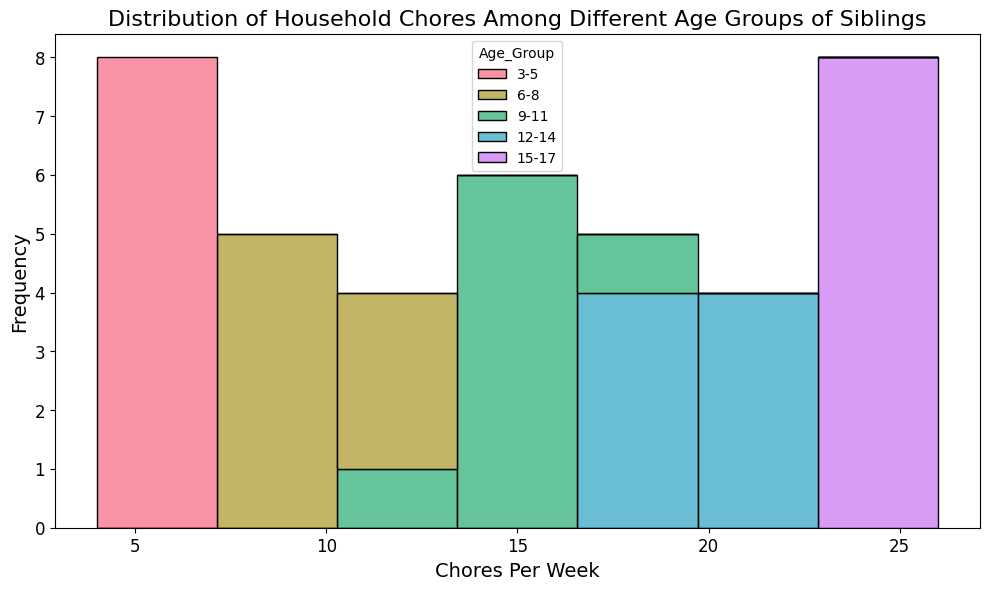How many more chores per week do the 15-17 age group complete compared to the 3-5 age group on average? First, calculate the average chores completed each week by both age groups. For the 15-17 age group, the average is (23+24+25+26+24+23+26+25)/8 = 24.5. For the 3-5 age group, the average is (5+4+6+4+5+7+6+5)/8 = 5.25. The difference in chores per week completed is 24.5 - 5.25 = 19.25
Answer: 19.25 Which age group has the highest frequency of completing 20 chores per week? Look at the histogram to identify the color corresponding to the bar at 20 chores per week. The highest frequency at this point belongs to the 12-14 age group, indicated by the bar at 20 chores per week.
Answer: 12-14 What is the range of the number of chores completed per week among the 9-11 age group? Identify the maximum and minimum number of chores completed per week for the 9-11 age group. The values range from 13 to 17. The range is 17 - 13 = 4.
Answer: 4 Are there any age groups that do not complete any chores at the 6 chores per week level? Observe which colored portions of the bars are missing at the 6 chores per week mark. Both the 6-8, 9-11, 12-14, and 15-17 age groups do not appear in this category.
Answer: 6-8, 9-11, 12-14, 15-17 Which age group has the most variation in the number of chores completed per week? Determine the spread of the data points for each age group. The 15-17 age group completes chores ranging from 23 to 26, while the 12-14 age group ranges from 18 to 22, 9-11 ranges from 13 to 17, 6-8 ranges from 8 to 13, and 3-5 ranges from 4 to 7. The 6-8 age group has the most variation with a range of 5 chores.
Answer: 6-8 